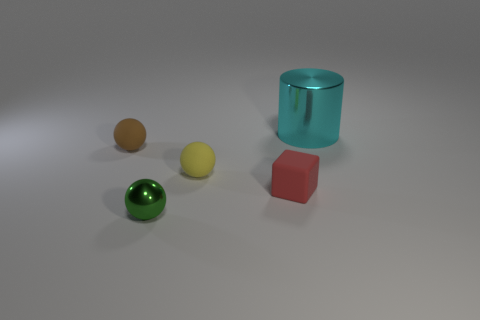Add 2 yellow matte things. How many objects exist? 7 Subtract all yellow cylinders. Subtract all gray spheres. How many cylinders are left? 1 Subtract all balls. How many objects are left? 2 Subtract 0 brown blocks. How many objects are left? 5 Subtract all metal cylinders. Subtract all shiny cylinders. How many objects are left? 3 Add 5 metallic cylinders. How many metallic cylinders are left? 6 Add 1 large gray rubber cylinders. How many large gray rubber cylinders exist? 1 